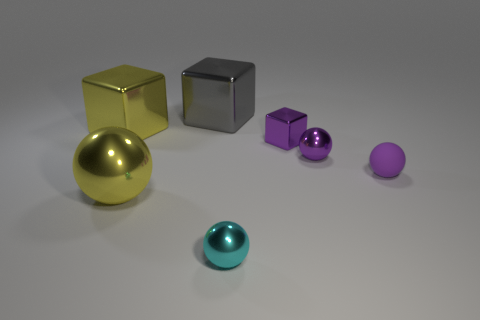Does the small metal cube have the same color as the big thing that is in front of the tiny purple metallic sphere?
Provide a succinct answer. No. What number of other objects are there of the same size as the matte sphere?
Your answer should be compact. 3. The large yellow object that is in front of the ball that is to the right of the purple metal object that is in front of the small purple cube is what shape?
Give a very brief answer. Sphere. Does the yellow metallic block have the same size as the shiny block that is on the right side of the large gray metallic block?
Provide a short and direct response. No. There is a block that is both in front of the large gray object and to the right of the large yellow ball; what color is it?
Offer a terse response. Purple. How many other objects are there of the same shape as the cyan object?
Offer a very short reply. 3. Do the small sphere that is in front of the small purple rubber thing and the metal cube that is in front of the large yellow cube have the same color?
Provide a succinct answer. No. Is the size of the metallic sphere that is behind the big yellow metal ball the same as the yellow metallic thing that is in front of the small purple matte ball?
Your answer should be compact. No. There is a large cube that is on the right side of the metallic cube that is to the left of the gray object behind the purple block; what is it made of?
Offer a terse response. Metal. Do the large gray object and the cyan object have the same shape?
Ensure brevity in your answer.  No. 